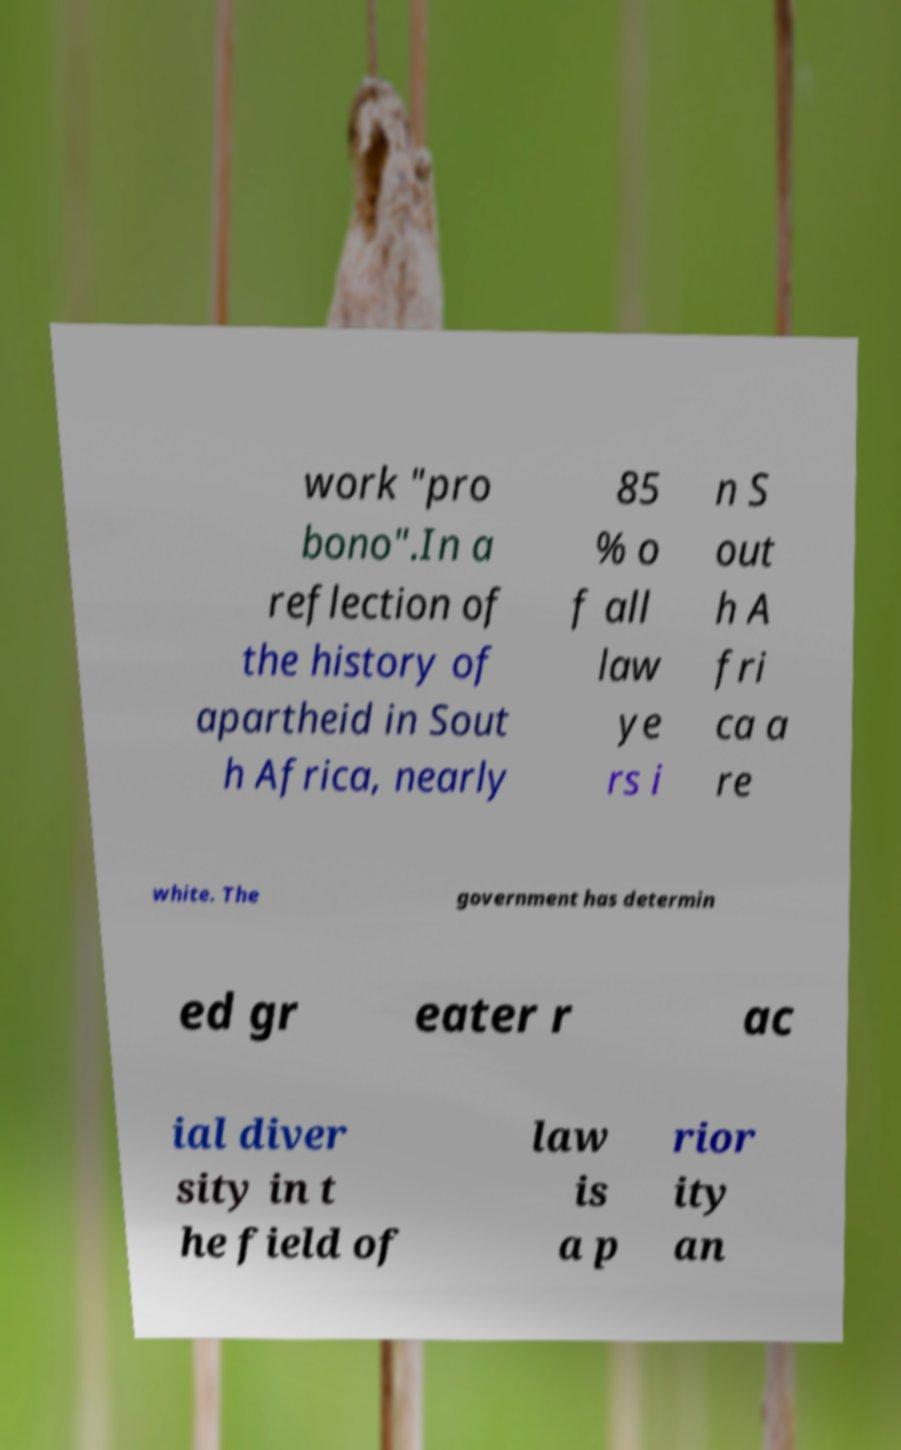Please read and relay the text visible in this image. What does it say? work "pro bono".In a reflection of the history of apartheid in Sout h Africa, nearly 85 % o f all law ye rs i n S out h A fri ca a re white. The government has determin ed gr eater r ac ial diver sity in t he field of law is a p rior ity an 